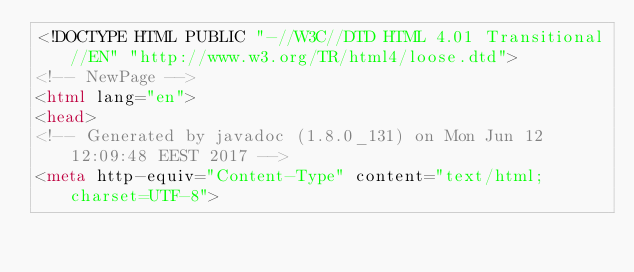Convert code to text. <code><loc_0><loc_0><loc_500><loc_500><_HTML_><!DOCTYPE HTML PUBLIC "-//W3C//DTD HTML 4.01 Transitional//EN" "http://www.w3.org/TR/html4/loose.dtd">
<!-- NewPage -->
<html lang="en">
<head>
<!-- Generated by javadoc (1.8.0_131) on Mon Jun 12 12:09:48 EEST 2017 -->
<meta http-equiv="Content-Type" content="text/html; charset=UTF-8"></code> 